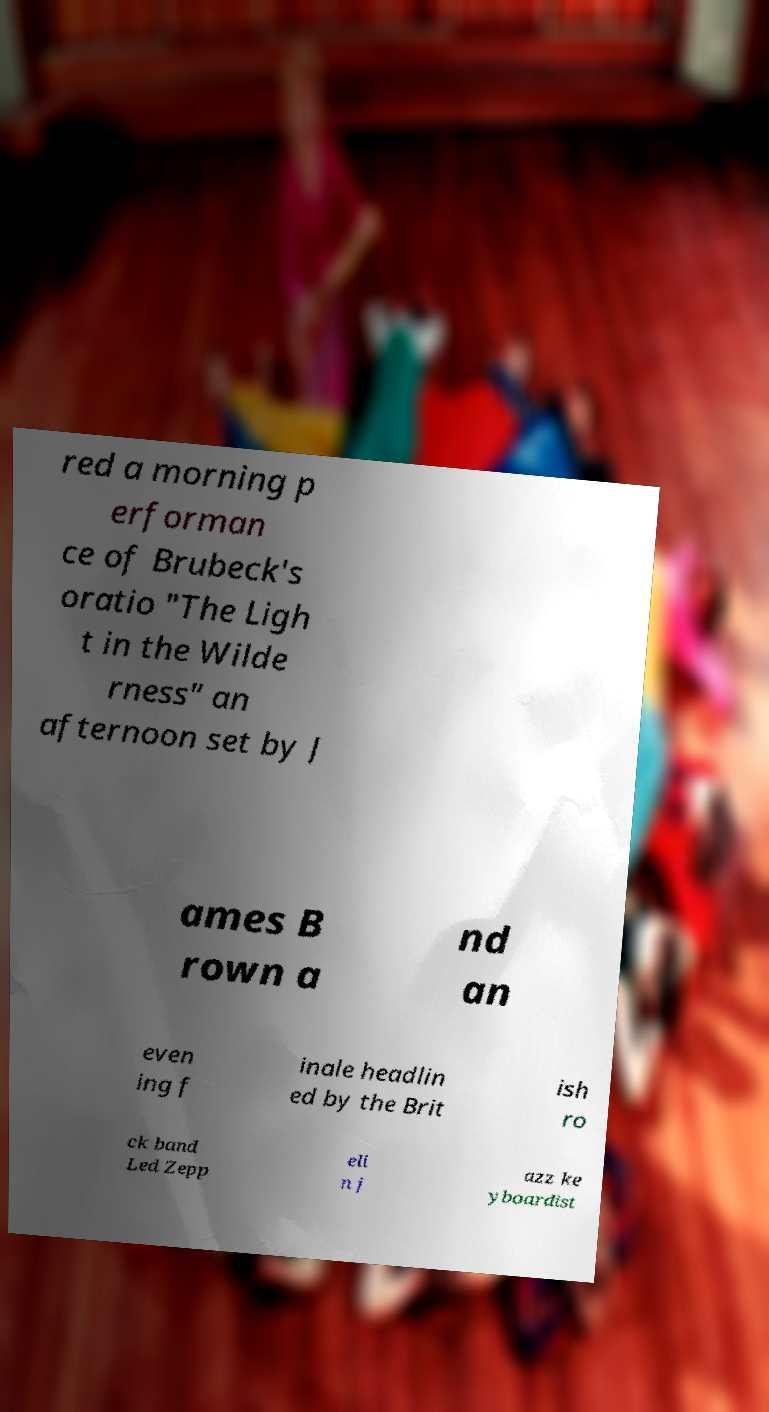I need the written content from this picture converted into text. Can you do that? red a morning p erforman ce of Brubeck's oratio "The Ligh t in the Wilde rness" an afternoon set by J ames B rown a nd an even ing f inale headlin ed by the Brit ish ro ck band Led Zepp eli n j azz ke yboardist 